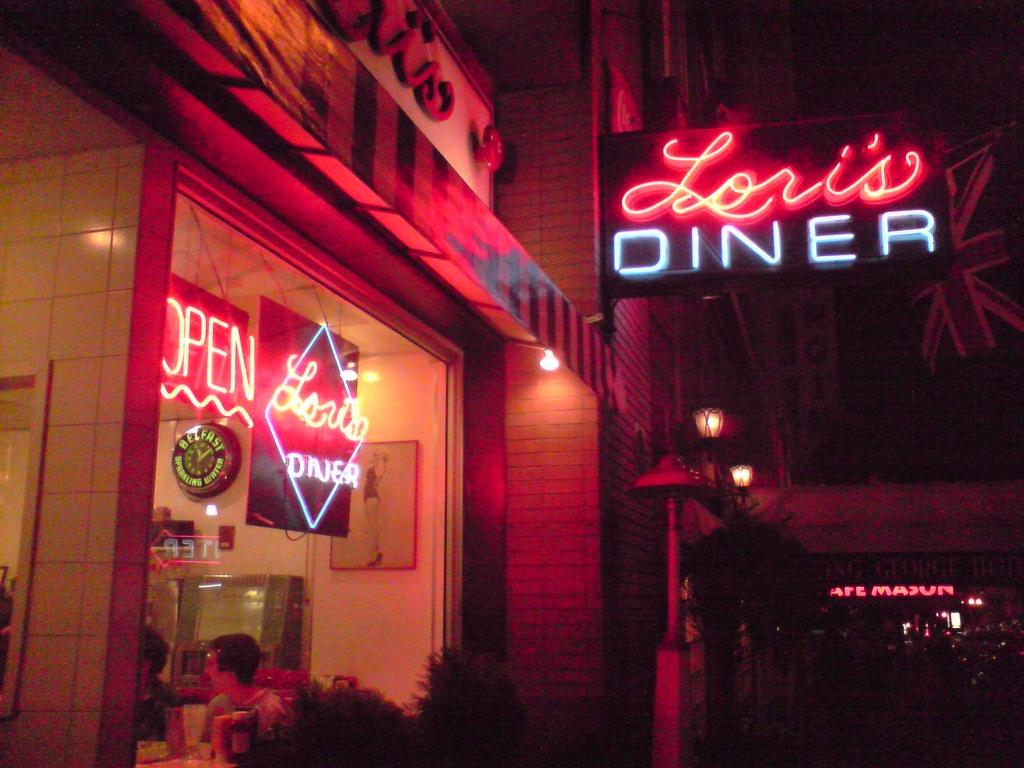<image>
Share a concise interpretation of the image provided. Lori's Diner has a neon sign that hangs over the sidewalk, and another in the window. 